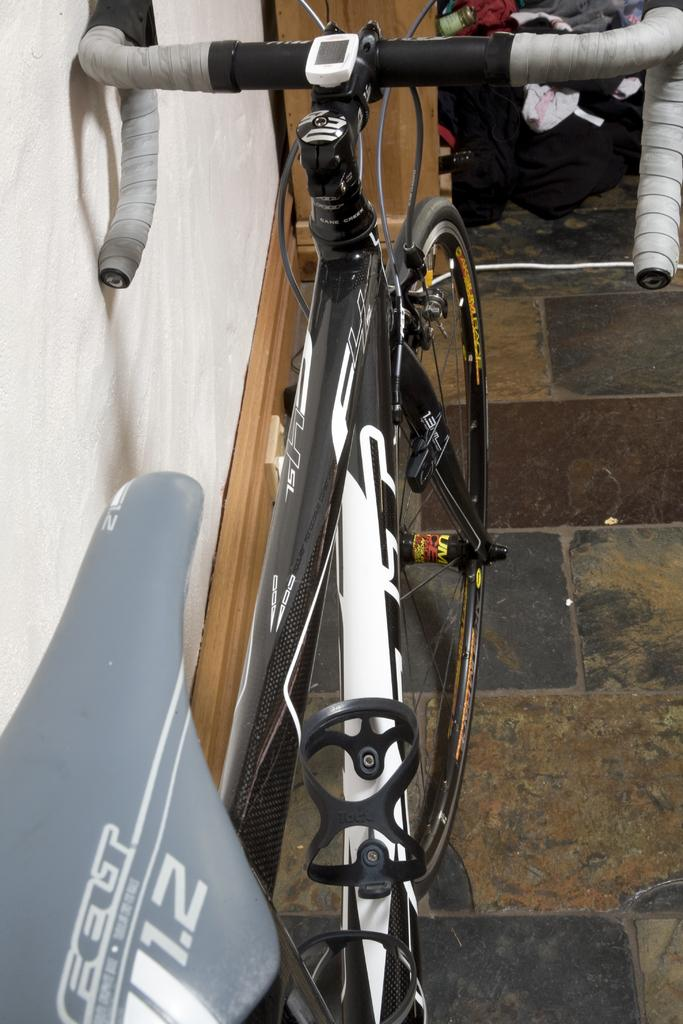What is the main object in the image? There is a cycle in the image. Where is the cycle located in relation to other objects? The cycle is held beside a wall. What other items can be seen in the image? There are wooden tools in front of the cycle. What type of beef is being prepared on the wooden tools in the image? There is no beef or any indication of food preparation in the image; it features a cycle held beside a wall with wooden tools in front of it. 